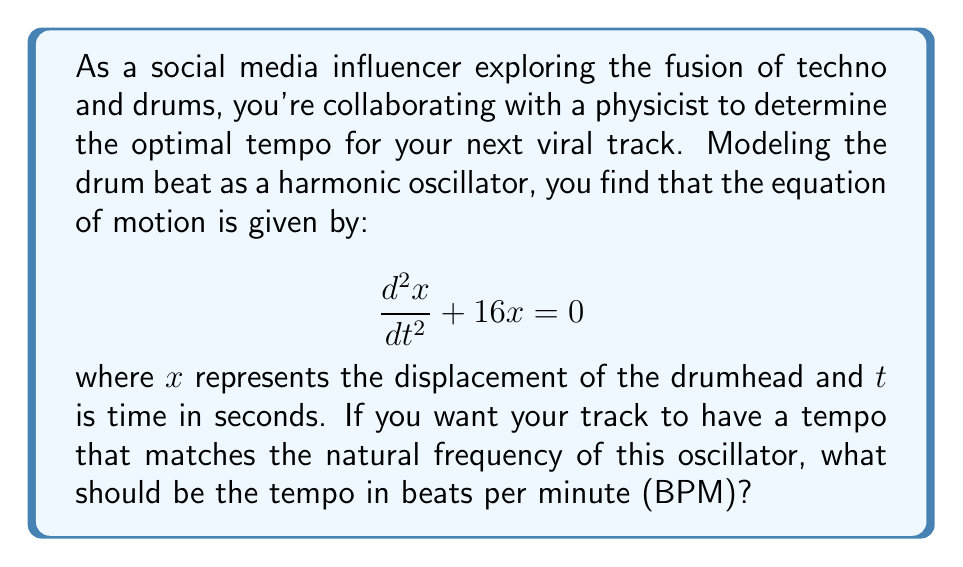Help me with this question. To solve this problem, we need to follow these steps:

1) The given equation is in the standard form of a simple harmonic oscillator:

   $$\frac{d^2x}{dt^2} + \omega^2x = 0$$

   where $\omega$ is the angular frequency in radians per second.

2) From our given equation, we can see that $\omega^2 = 16$, so:

   $$\omega = \sqrt{16} = 4 \text{ rad/s}$$

3) To convert angular frequency to frequency in Hz, we use the relation:

   $$f = \frac{\omega}{2\pi}$$

   Substituting our value:

   $$f = \frac{4}{2\pi} = \frac{2}{\pi} \text{ Hz}$$

4) Now, we need to convert this frequency to beats per minute (BPM). Since there are 60 seconds in a minute:

   $$\text{BPM} = f * 60$$

   Substituting our frequency:

   $$\text{BPM} = \frac{2}{\pi} * 60 = \frac{120}{\pi}$$

5) Calculating this value:

   $$\text{BPM} \approx 38.2$$

6) Since BPM is typically expressed as an integer, we should round this to the nearest whole number: 38 BPM.
Answer: 38 BPM 